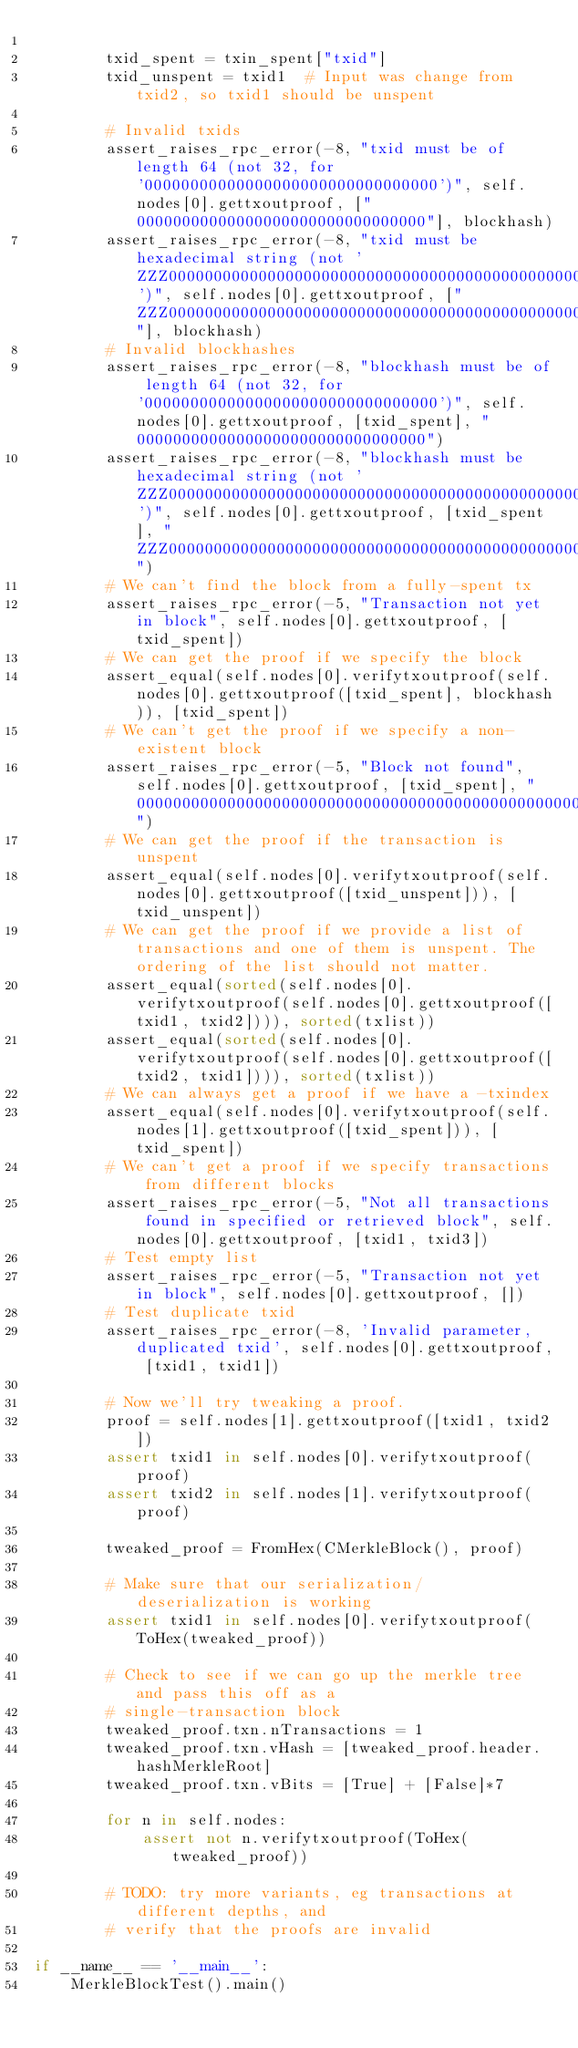<code> <loc_0><loc_0><loc_500><loc_500><_Python_>
        txid_spent = txin_spent["txid"]
        txid_unspent = txid1  # Input was change from txid2, so txid1 should be unspent

        # Invalid txids
        assert_raises_rpc_error(-8, "txid must be of length 64 (not 32, for '00000000000000000000000000000000')", self.nodes[0].gettxoutproof, ["00000000000000000000000000000000"], blockhash)
        assert_raises_rpc_error(-8, "txid must be hexadecimal string (not 'ZZZ0000000000000000000000000000000000000000000000000000000000000')", self.nodes[0].gettxoutproof, ["ZZZ0000000000000000000000000000000000000000000000000000000000000"], blockhash)
        # Invalid blockhashes
        assert_raises_rpc_error(-8, "blockhash must be of length 64 (not 32, for '00000000000000000000000000000000')", self.nodes[0].gettxoutproof, [txid_spent], "00000000000000000000000000000000")
        assert_raises_rpc_error(-8, "blockhash must be hexadecimal string (not 'ZZZ0000000000000000000000000000000000000000000000000000000000000')", self.nodes[0].gettxoutproof, [txid_spent], "ZZZ0000000000000000000000000000000000000000000000000000000000000")
        # We can't find the block from a fully-spent tx
        assert_raises_rpc_error(-5, "Transaction not yet in block", self.nodes[0].gettxoutproof, [txid_spent])
        # We can get the proof if we specify the block
        assert_equal(self.nodes[0].verifytxoutproof(self.nodes[0].gettxoutproof([txid_spent], blockhash)), [txid_spent])
        # We can't get the proof if we specify a non-existent block
        assert_raises_rpc_error(-5, "Block not found", self.nodes[0].gettxoutproof, [txid_spent], "0000000000000000000000000000000000000000000000000000000000000000")
        # We can get the proof if the transaction is unspent
        assert_equal(self.nodes[0].verifytxoutproof(self.nodes[0].gettxoutproof([txid_unspent])), [txid_unspent])
        # We can get the proof if we provide a list of transactions and one of them is unspent. The ordering of the list should not matter.
        assert_equal(sorted(self.nodes[0].verifytxoutproof(self.nodes[0].gettxoutproof([txid1, txid2]))), sorted(txlist))
        assert_equal(sorted(self.nodes[0].verifytxoutproof(self.nodes[0].gettxoutproof([txid2, txid1]))), sorted(txlist))
        # We can always get a proof if we have a -txindex
        assert_equal(self.nodes[0].verifytxoutproof(self.nodes[1].gettxoutproof([txid_spent])), [txid_spent])
        # We can't get a proof if we specify transactions from different blocks
        assert_raises_rpc_error(-5, "Not all transactions found in specified or retrieved block", self.nodes[0].gettxoutproof, [txid1, txid3])
        # Test empty list
        assert_raises_rpc_error(-5, "Transaction not yet in block", self.nodes[0].gettxoutproof, [])
        # Test duplicate txid
        assert_raises_rpc_error(-8, 'Invalid parameter, duplicated txid', self.nodes[0].gettxoutproof, [txid1, txid1])

        # Now we'll try tweaking a proof.
        proof = self.nodes[1].gettxoutproof([txid1, txid2])
        assert txid1 in self.nodes[0].verifytxoutproof(proof)
        assert txid2 in self.nodes[1].verifytxoutproof(proof)

        tweaked_proof = FromHex(CMerkleBlock(), proof)

        # Make sure that our serialization/deserialization is working
        assert txid1 in self.nodes[0].verifytxoutproof(ToHex(tweaked_proof))

        # Check to see if we can go up the merkle tree and pass this off as a
        # single-transaction block
        tweaked_proof.txn.nTransactions = 1
        tweaked_proof.txn.vHash = [tweaked_proof.header.hashMerkleRoot]
        tweaked_proof.txn.vBits = [True] + [False]*7

        for n in self.nodes:
            assert not n.verifytxoutproof(ToHex(tweaked_proof))

        # TODO: try more variants, eg transactions at different depths, and
        # verify that the proofs are invalid

if __name__ == '__main__':
    MerkleBlockTest().main()
</code> 